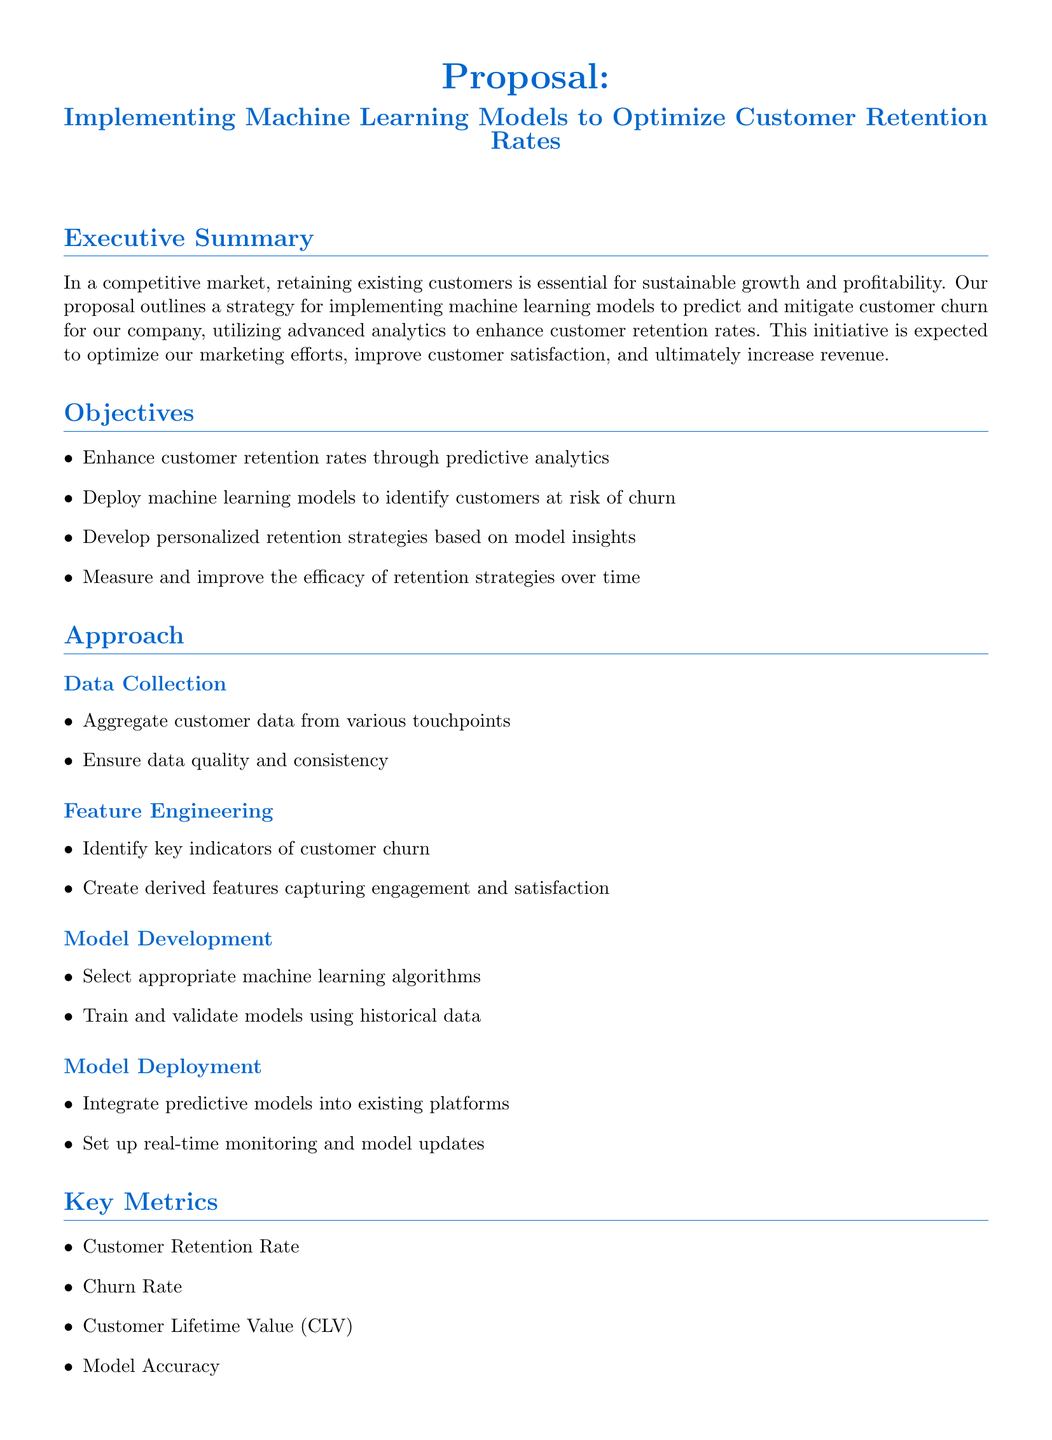What is the primary goal of the proposal? The primary goal is to implement machine learning models to predict and mitigate customer churn.
Answer: Predict and mitigate customer churn How long is the model development and validation phase? The duration of the model development and validation phase is specified in the document.
Answer: 2 months What is the estimated cost for data collection and preprocessing? The cost is detailed in the budget estimate section.
Answer: 20,000 USD Which key metric is related to customer loyalty? This metric is associated with maintaining loyal customers, mentioned in the key metrics section.
Answer: Customer Retention Rate What aspect of customer behavior will be focused on for feature engineering? This refers to attributes indicating customer relationship strength.
Answer: Engagement and satisfaction What is the ongoing cost for monitoring and optimization? The document specifies a recurring expense for the related phase.
Answer: 15,000 USD annually What type of models will be integrated into existing platforms? The proposal emphasizes the use of predictive analytics for specific customer outcomes.
Answer: Predictive models What is the total duration for the entire implementation process? This total is derived from the individual phase durations in the timeline.
Answer: 4 months What should be measured to evaluate retention strategies? This is a critical component of assessing the overall effectiveness of the strategies developed.
Answer: Efficacy of retention strategies 